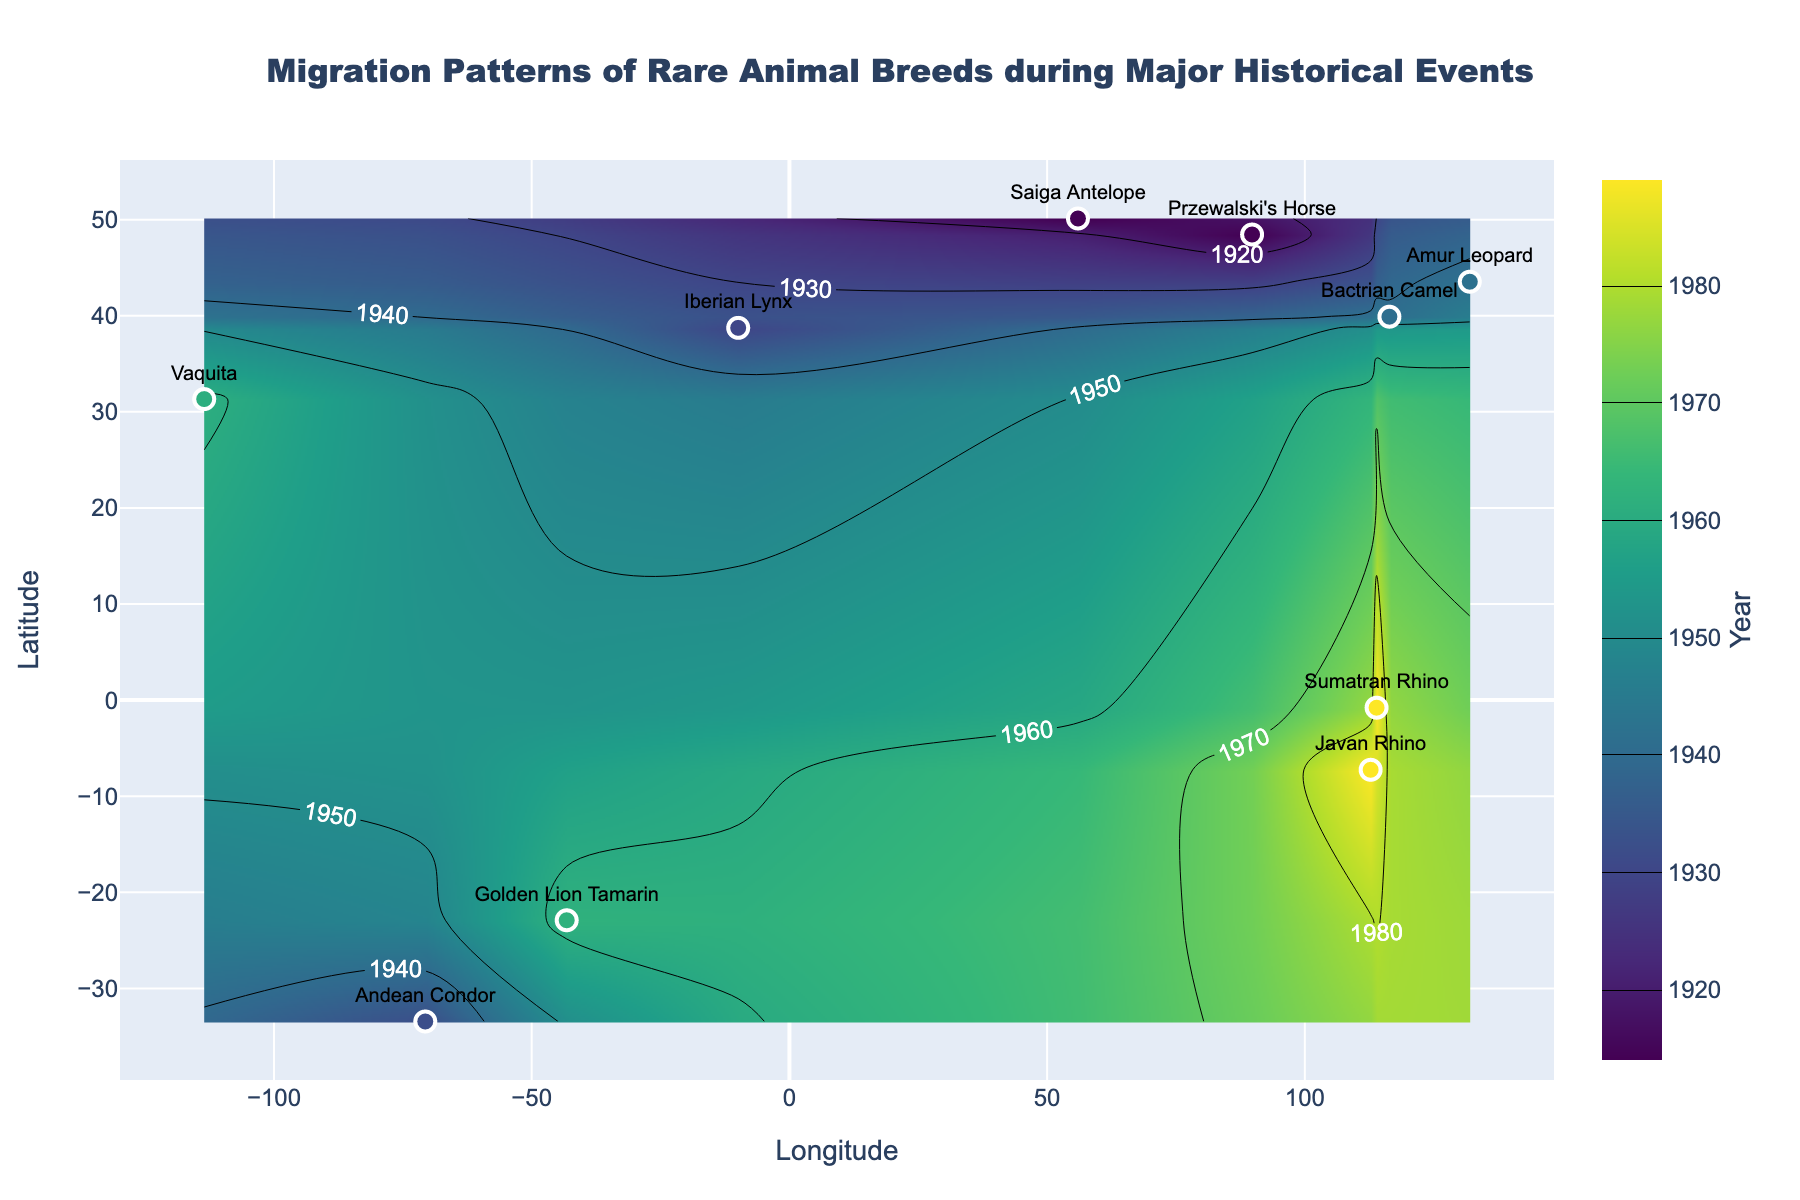what is the title of the plot? Look at the top of the plot for the text in the title position.
Answer: Migration Patterns of Rare Animal Breeds during Major Historical Events How many historical events are represented by the migration patterns? Count the unique historical events mentioned alongside the species in the plot markers or hover information.
Answer: 5 Which historical event is associated with the earliest year in the data? Identify the event marker with the earliest year (smallest year value) in the plot.
Answer: World War I Which species have migration patterns marked in South America? Locate the points on the plot that fall within the latitude and longitude of South America and identify the species.
Answer: Andean Condor, Golden Lion Tamarin What time period does the highest latitude point on the plot correspond to? Find the point with the highest latitude value and check its year label.
Answer: 1914 Of the species marked during the Cold War, which one is geographically located further east? Identify the points labeled with the Cold War period, and then compare their longitudinal values to determine which is further east (higher longitude).
Answer: Golden Lion Tamarin During which historical event did the Iberian Lynx migrate, and in what year? Look for the Iberian Lynx label in the plot and note the associated historical event and year.
Answer: Great Depression, 1930 Are there any species migrations that occurred in the same year? If so, which ones? Check for any overlapping year values in the plot and identify the corresponding species.
Answer: Sumatran Rhino, Javan Rhino What is the northernmost migration recorded on the plot, and which species does it represent? Identify the highest latitude in the plot and check the species associated with that point.
Answer: Saiga Antelope Which historical event is associated with the southernmost migration in the plot? Find the point with the lowest latitude value and identify the historical event associated with it.
Answer: Great Depression 